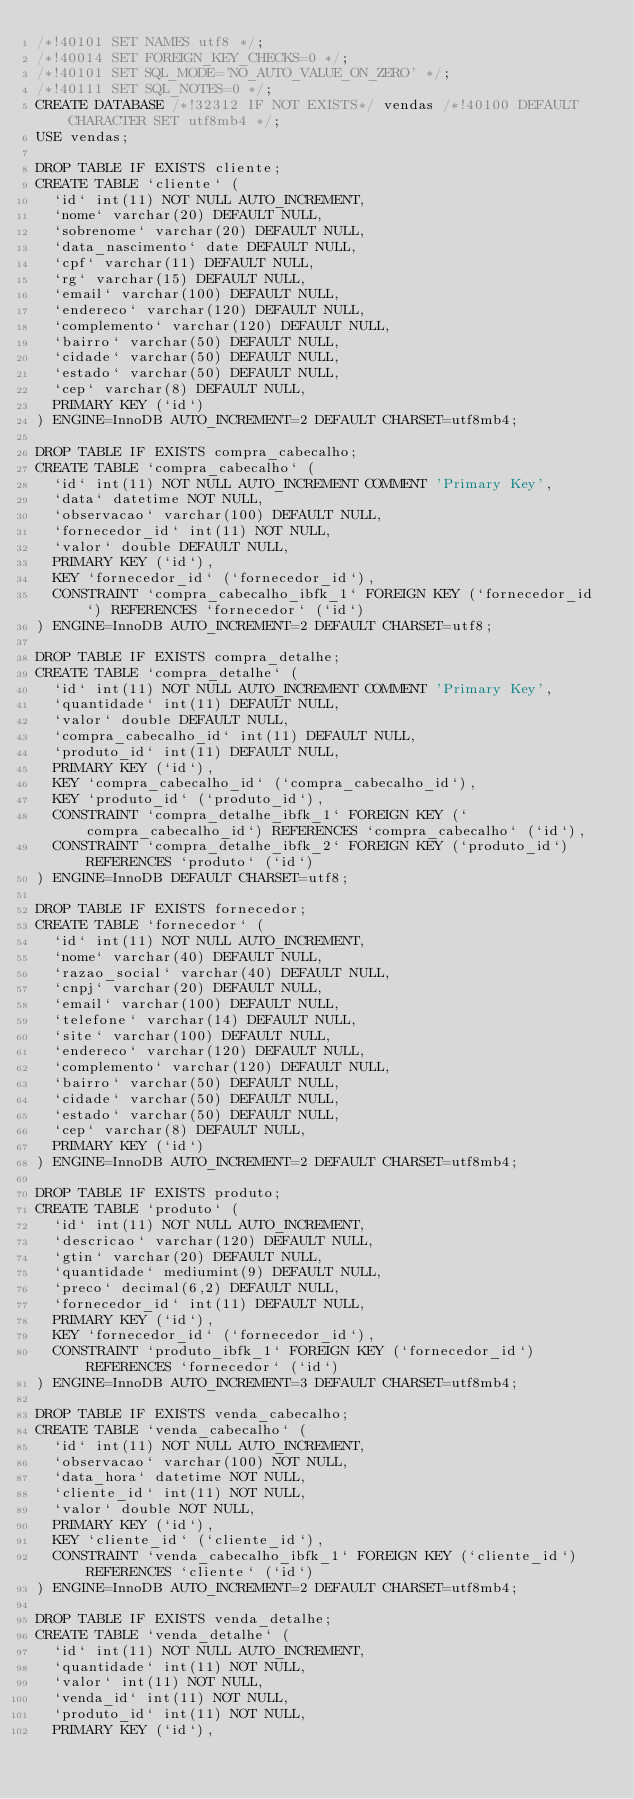<code> <loc_0><loc_0><loc_500><loc_500><_SQL_>/*!40101 SET NAMES utf8 */;
/*!40014 SET FOREIGN_KEY_CHECKS=0 */;
/*!40101 SET SQL_MODE='NO_AUTO_VALUE_ON_ZERO' */;
/*!40111 SET SQL_NOTES=0 */;
CREATE DATABASE /*!32312 IF NOT EXISTS*/ vendas /*!40100 DEFAULT CHARACTER SET utf8mb4 */;
USE vendas;

DROP TABLE IF EXISTS cliente;
CREATE TABLE `cliente` (
  `id` int(11) NOT NULL AUTO_INCREMENT,
  `nome` varchar(20) DEFAULT NULL,
  `sobrenome` varchar(20) DEFAULT NULL,
  `data_nascimento` date DEFAULT NULL,
  `cpf` varchar(11) DEFAULT NULL,
  `rg` varchar(15) DEFAULT NULL,
  `email` varchar(100) DEFAULT NULL,
  `endereco` varchar(120) DEFAULT NULL,
  `complemento` varchar(120) DEFAULT NULL,
  `bairro` varchar(50) DEFAULT NULL,
  `cidade` varchar(50) DEFAULT NULL,
  `estado` varchar(50) DEFAULT NULL,
  `cep` varchar(8) DEFAULT NULL,
  PRIMARY KEY (`id`)
) ENGINE=InnoDB AUTO_INCREMENT=2 DEFAULT CHARSET=utf8mb4;

DROP TABLE IF EXISTS compra_cabecalho;
CREATE TABLE `compra_cabecalho` (
  `id` int(11) NOT NULL AUTO_INCREMENT COMMENT 'Primary Key',
  `data` datetime NOT NULL,
  `observacao` varchar(100) DEFAULT NULL,
  `fornecedor_id` int(11) NOT NULL,
  `valor` double DEFAULT NULL,
  PRIMARY KEY (`id`),
  KEY `fornecedor_id` (`fornecedor_id`),
  CONSTRAINT `compra_cabecalho_ibfk_1` FOREIGN KEY (`fornecedor_id`) REFERENCES `fornecedor` (`id`)
) ENGINE=InnoDB AUTO_INCREMENT=2 DEFAULT CHARSET=utf8;

DROP TABLE IF EXISTS compra_detalhe;
CREATE TABLE `compra_detalhe` (
  `id` int(11) NOT NULL AUTO_INCREMENT COMMENT 'Primary Key',
  `quantidade` int(11) DEFAULT NULL,
  `valor` double DEFAULT NULL,
  `compra_cabecalho_id` int(11) DEFAULT NULL,
  `produto_id` int(11) DEFAULT NULL,
  PRIMARY KEY (`id`),
  KEY `compra_cabecalho_id` (`compra_cabecalho_id`),
  KEY `produto_id` (`produto_id`),
  CONSTRAINT `compra_detalhe_ibfk_1` FOREIGN KEY (`compra_cabecalho_id`) REFERENCES `compra_cabecalho` (`id`),
  CONSTRAINT `compra_detalhe_ibfk_2` FOREIGN KEY (`produto_id`) REFERENCES `produto` (`id`)
) ENGINE=InnoDB DEFAULT CHARSET=utf8;

DROP TABLE IF EXISTS fornecedor;
CREATE TABLE `fornecedor` (
  `id` int(11) NOT NULL AUTO_INCREMENT,
  `nome` varchar(40) DEFAULT NULL,
  `razao_social` varchar(40) DEFAULT NULL,
  `cnpj` varchar(20) DEFAULT NULL,
  `email` varchar(100) DEFAULT NULL,
  `telefone` varchar(14) DEFAULT NULL,
  `site` varchar(100) DEFAULT NULL,
  `endereco` varchar(120) DEFAULT NULL,
  `complemento` varchar(120) DEFAULT NULL,
  `bairro` varchar(50) DEFAULT NULL,
  `cidade` varchar(50) DEFAULT NULL,
  `estado` varchar(50) DEFAULT NULL,
  `cep` varchar(8) DEFAULT NULL,
  PRIMARY KEY (`id`)
) ENGINE=InnoDB AUTO_INCREMENT=2 DEFAULT CHARSET=utf8mb4;

DROP TABLE IF EXISTS produto;
CREATE TABLE `produto` (
  `id` int(11) NOT NULL AUTO_INCREMENT,
  `descricao` varchar(120) DEFAULT NULL,
  `gtin` varchar(20) DEFAULT NULL,
  `quantidade` mediumint(9) DEFAULT NULL,
  `preco` decimal(6,2) DEFAULT NULL,
  `fornecedor_id` int(11) DEFAULT NULL,
  PRIMARY KEY (`id`),
  KEY `fornecedor_id` (`fornecedor_id`),
  CONSTRAINT `produto_ibfk_1` FOREIGN KEY (`fornecedor_id`) REFERENCES `fornecedor` (`id`)
) ENGINE=InnoDB AUTO_INCREMENT=3 DEFAULT CHARSET=utf8mb4;

DROP TABLE IF EXISTS venda_cabecalho;
CREATE TABLE `venda_cabecalho` (
  `id` int(11) NOT NULL AUTO_INCREMENT,
  `observacao` varchar(100) NOT NULL,
  `data_hora` datetime NOT NULL,
  `cliente_id` int(11) NOT NULL,
  `valor` double NOT NULL,
  PRIMARY KEY (`id`),
  KEY `cliente_id` (`cliente_id`),
  CONSTRAINT `venda_cabecalho_ibfk_1` FOREIGN KEY (`cliente_id`) REFERENCES `cliente` (`id`)
) ENGINE=InnoDB AUTO_INCREMENT=2 DEFAULT CHARSET=utf8mb4;

DROP TABLE IF EXISTS venda_detalhe;
CREATE TABLE `venda_detalhe` (
  `id` int(11) NOT NULL AUTO_INCREMENT,
  `quantidade` int(11) NOT NULL,
  `valor` int(11) NOT NULL,
  `venda_id` int(11) NOT NULL,
  `produto_id` int(11) NOT NULL,
  PRIMARY KEY (`id`),</code> 